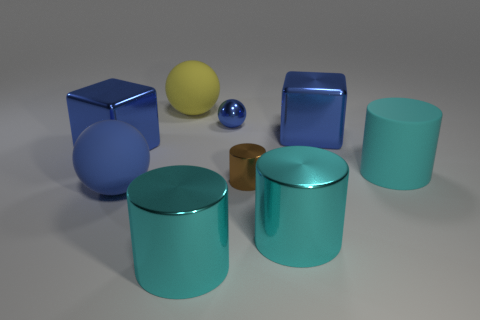There is a large object right of the large blue shiny object to the right of the tiny sphere; what shape is it?
Offer a terse response. Cylinder. What shape is the big blue thing that is behind the blue shiny cube to the left of the metal cylinder behind the large blue sphere?
Provide a short and direct response. Cube. How many large blue objects are the same shape as the large yellow object?
Offer a very short reply. 1. What number of blue blocks are in front of the large blue metallic cube that is on the right side of the big yellow rubber sphere?
Give a very brief answer. 1. What number of rubber objects are brown things or gray cylinders?
Offer a very short reply. 0. Is there a sphere that has the same material as the tiny brown cylinder?
Offer a very short reply. Yes. What number of things are large things that are right of the brown object or big matte spheres that are behind the blue rubber ball?
Provide a short and direct response. 4. There is a small object on the right side of the tiny ball; is it the same color as the tiny metallic sphere?
Offer a terse response. No. What number of other things are there of the same color as the tiny sphere?
Your answer should be very brief. 3. What material is the yellow object?
Give a very brief answer. Rubber. 